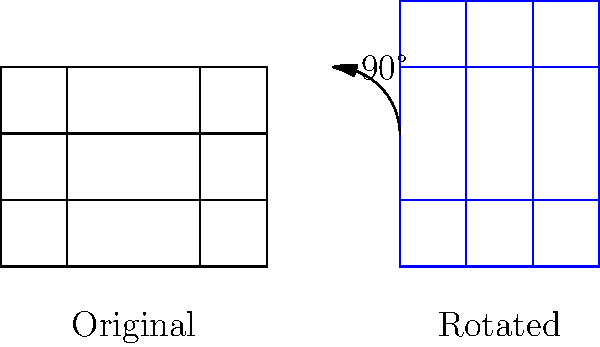A community development worker is designing a neighborhood park. The original design is a $4\times3$ rectangle with walkways dividing it into 12 equal squares. If the design needs to be rotated 90 degrees clockwise to fit the available land, what will be the dimensions of the new park design? To solve this problem, we need to understand how rotation affects the dimensions of a rectangle:

1. In the original design, the park is a $4\times3$ rectangle.
2. When rotating a rectangle by 90 degrees, the width becomes the height and the height becomes the width.
3. Therefore, after rotation:
   - The new width will be the original height: 3 units
   - The new height will be the original width: 4 units

4. The internal structure (walkways dividing the park into 12 equal squares) will also rotate, but this doesn't affect the overall dimensions.

5. So, the dimensions of the new park design after 90-degree clockwise rotation will be $3\times4$.

This transformation showcases how geometric principles can be applied in practical community development scenarios, demonstrating the importance of spatial awareness in urban planning.
Answer: $3\times4$ 